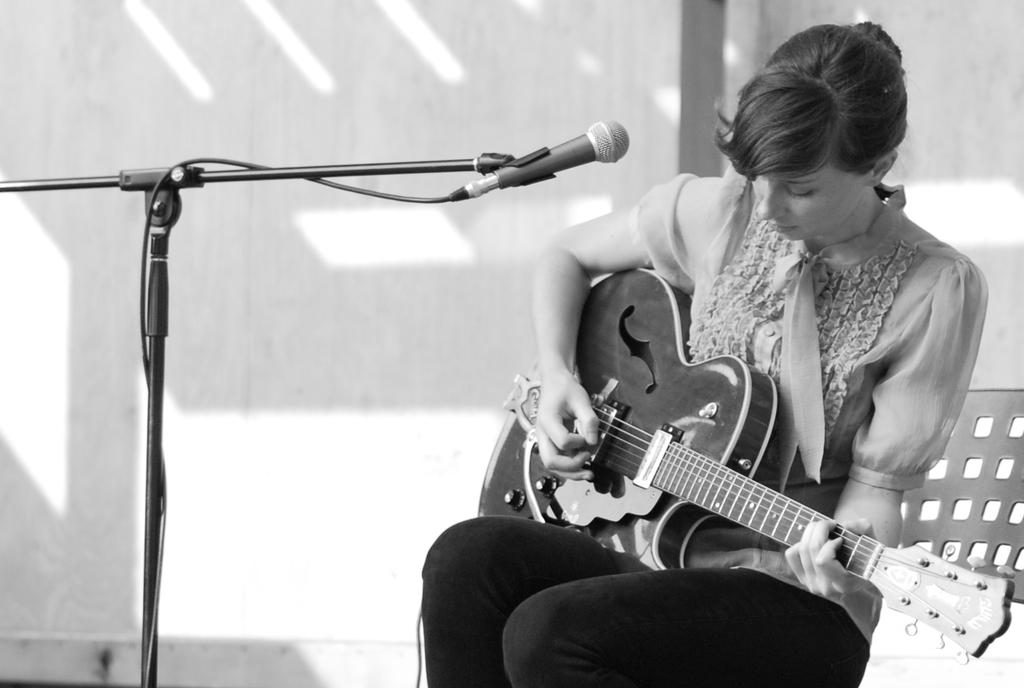Who is the main subject in the image? There is a woman in the image. What is the woman doing in the image? The woman is sitting and playing a guitar. What object is in front of the woman? There is a microphone in front of the woman. What can be seen in the background of the image? There is a wall in the background of the image. What type of air is being used by the woman to play the guitar in the image? The image does not provide information about the type of air being used by the woman to play the guitar. Is the woman performing on a stage in the image? The image does not show the woman on a stage; it only shows her sitting and playing a guitar with a microphone in front of her and a wall in the background. 